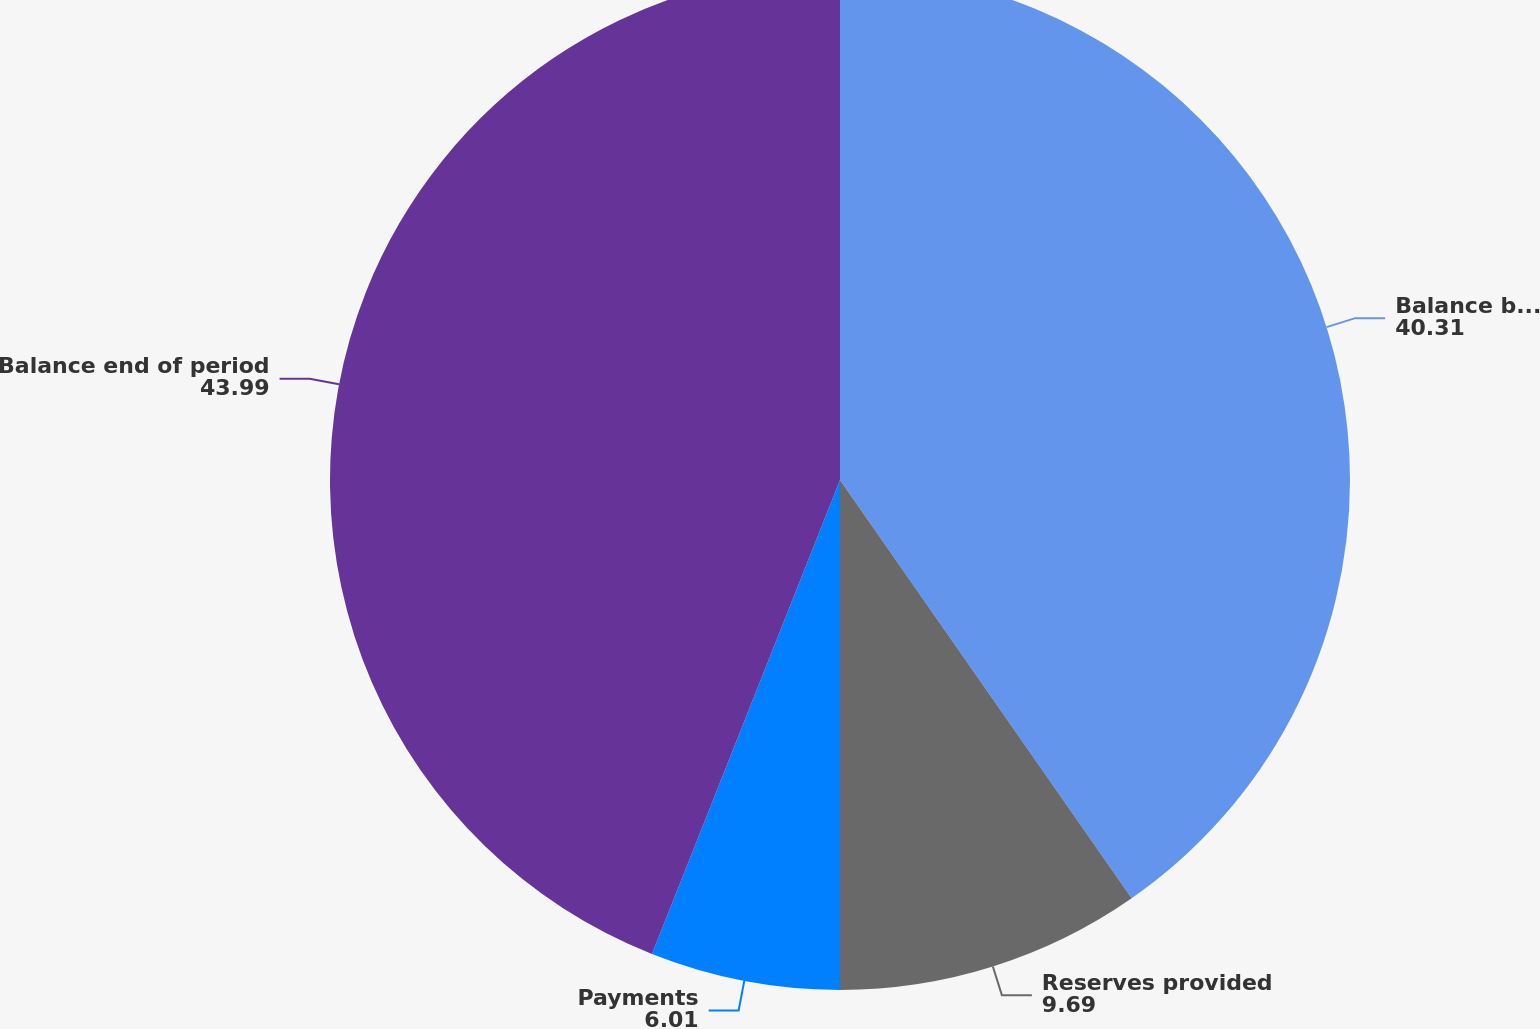Convert chart to OTSL. <chart><loc_0><loc_0><loc_500><loc_500><pie_chart><fcel>Balance beginning of period<fcel>Reserves provided<fcel>Payments<fcel>Balance end of period<nl><fcel>40.31%<fcel>9.69%<fcel>6.01%<fcel>43.99%<nl></chart> 